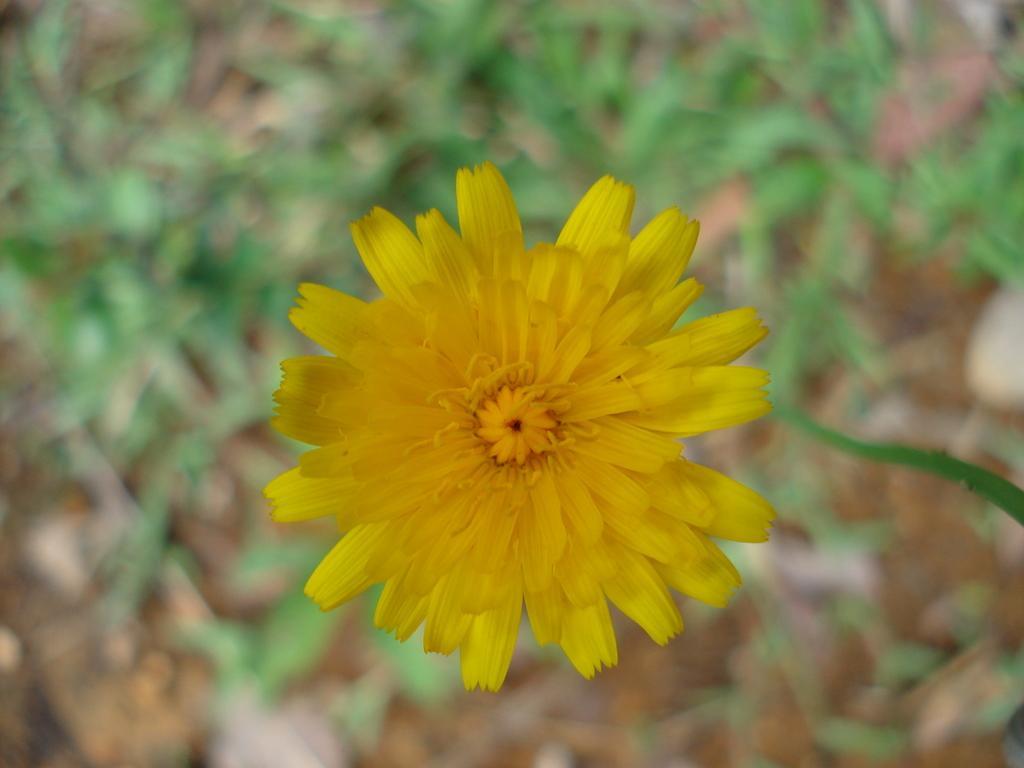Can you describe this image briefly? In this image we can see a yellow color flower and a blurry background. 